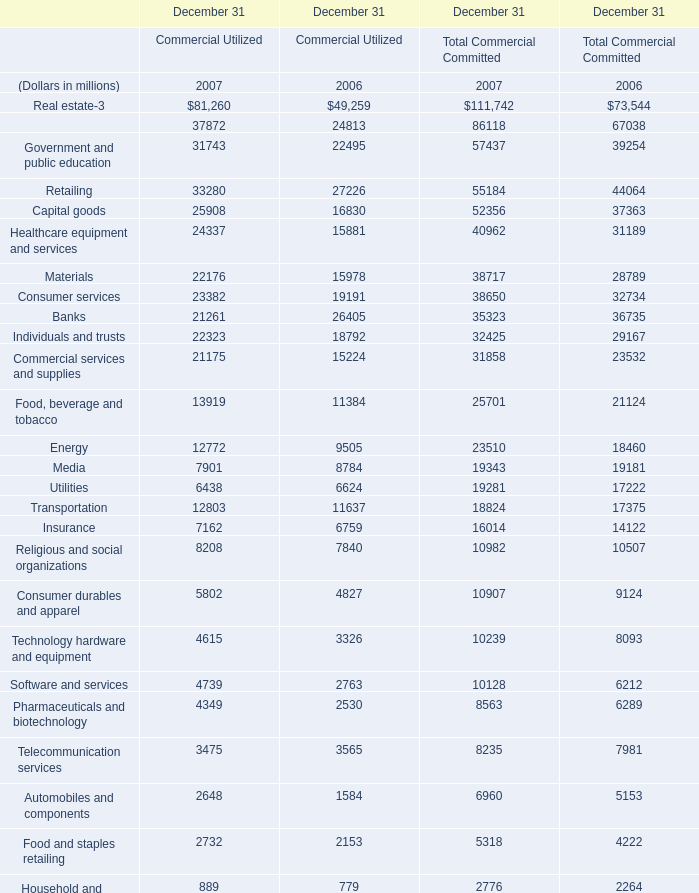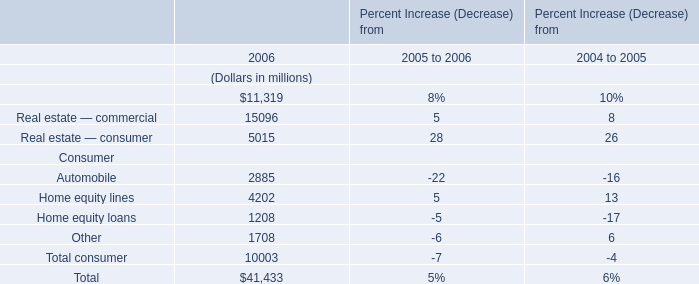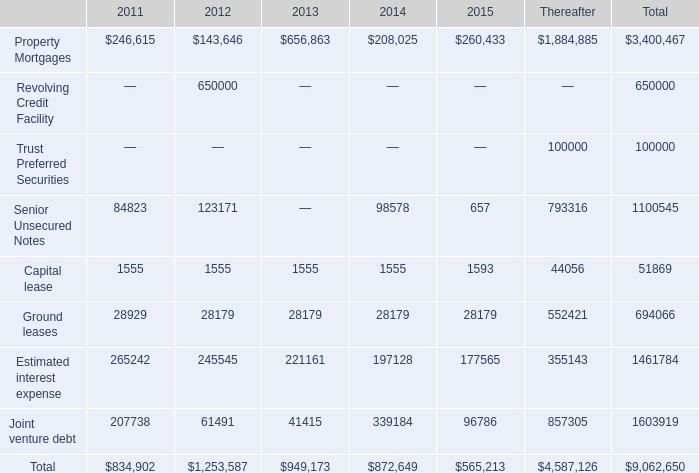What is the difference between the greatest Government and public education in 2006 and 2007？ (in million) 
Computations: ((31743 + 57437) - (22495 + 39254))
Answer: 27431.0. 